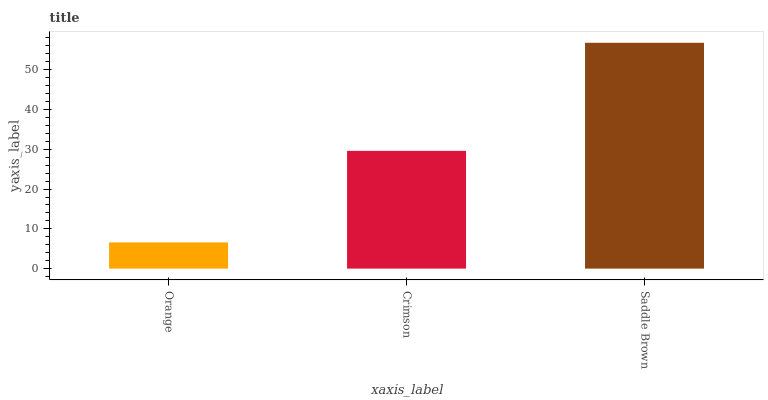Is Orange the minimum?
Answer yes or no. Yes. Is Saddle Brown the maximum?
Answer yes or no. Yes. Is Crimson the minimum?
Answer yes or no. No. Is Crimson the maximum?
Answer yes or no. No. Is Crimson greater than Orange?
Answer yes or no. Yes. Is Orange less than Crimson?
Answer yes or no. Yes. Is Orange greater than Crimson?
Answer yes or no. No. Is Crimson less than Orange?
Answer yes or no. No. Is Crimson the high median?
Answer yes or no. Yes. Is Crimson the low median?
Answer yes or no. Yes. Is Saddle Brown the high median?
Answer yes or no. No. Is Saddle Brown the low median?
Answer yes or no. No. 